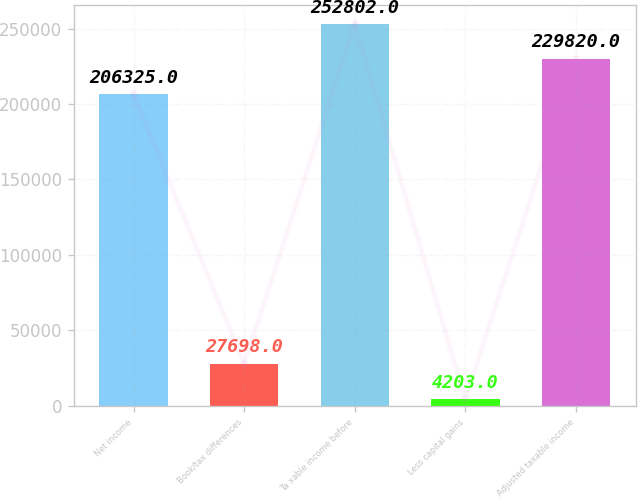Convert chart to OTSL. <chart><loc_0><loc_0><loc_500><loc_500><bar_chart><fcel>Net income<fcel>Book/tax differences<fcel>Ta xable income before<fcel>Less capital gains<fcel>Adjusted taxable income<nl><fcel>206325<fcel>27698<fcel>252802<fcel>4203<fcel>229820<nl></chart> 